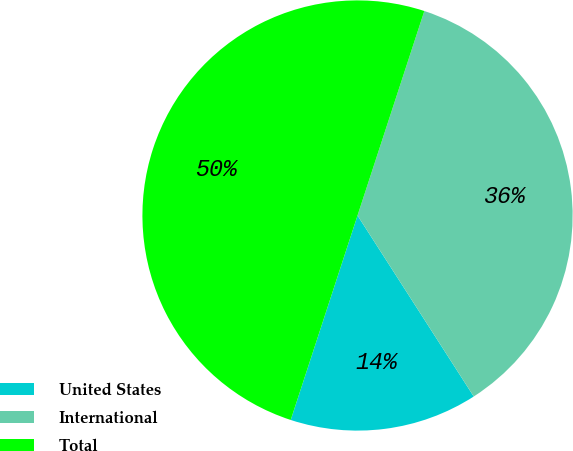<chart> <loc_0><loc_0><loc_500><loc_500><pie_chart><fcel>United States<fcel>International<fcel>Total<nl><fcel>14.11%<fcel>35.89%<fcel>50.0%<nl></chart> 